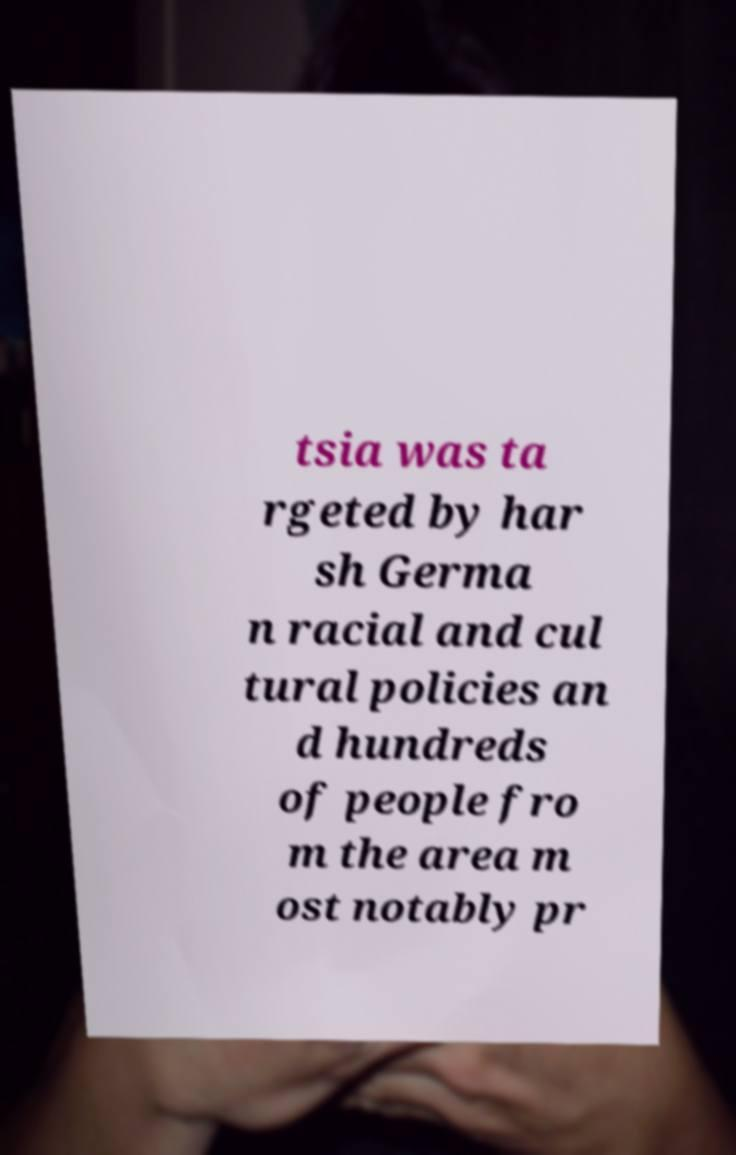For documentation purposes, I need the text within this image transcribed. Could you provide that? tsia was ta rgeted by har sh Germa n racial and cul tural policies an d hundreds of people fro m the area m ost notably pr 